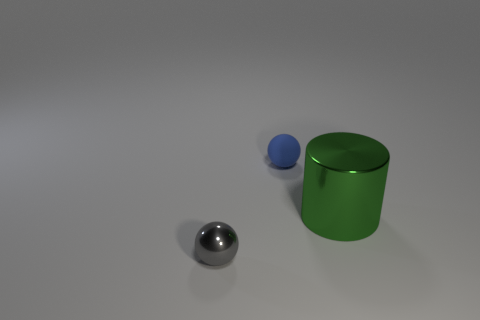Are there fewer tiny blue rubber spheres to the right of the large metal cylinder than tiny gray metal objects behind the rubber ball? Upon reviewing the image, there is only one tiny blue rubber sphere to the right of the large metal cylinder and one tiny gray metal object behind the rubber ball. Therefore, the number of tiny blue rubber spheres is equal to the number of tiny gray metal objects in the specified locations. 